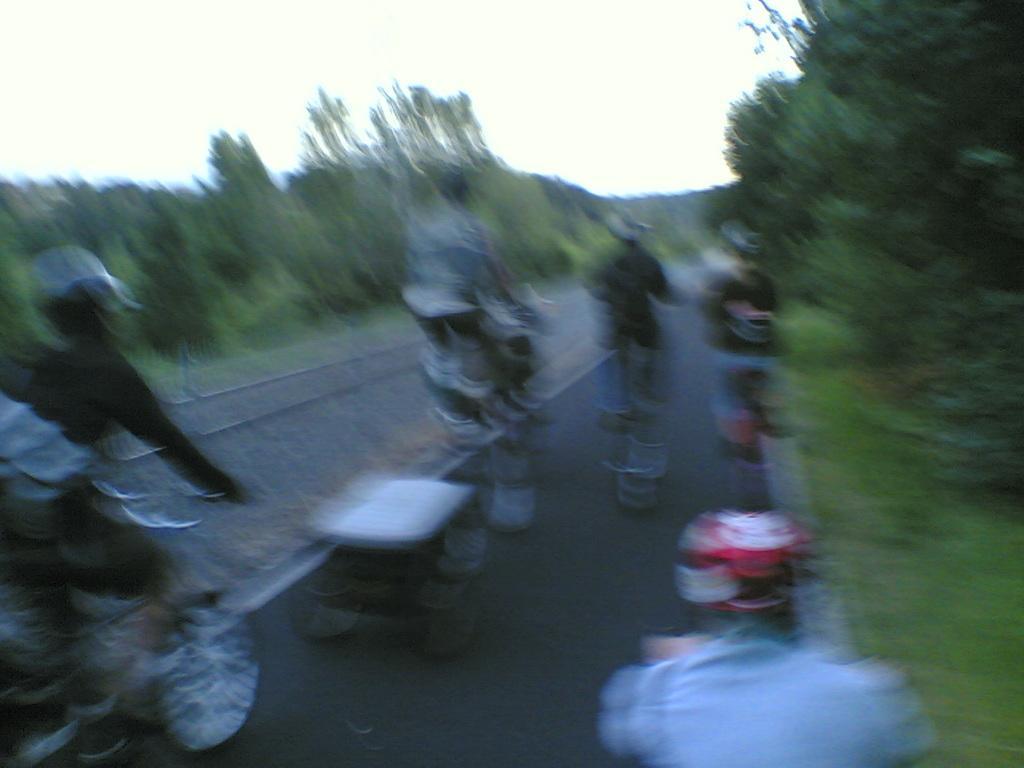In one or two sentences, can you explain what this image depicts? In this image, we can see people riding bicycles on the road and in the background, there are trees. 